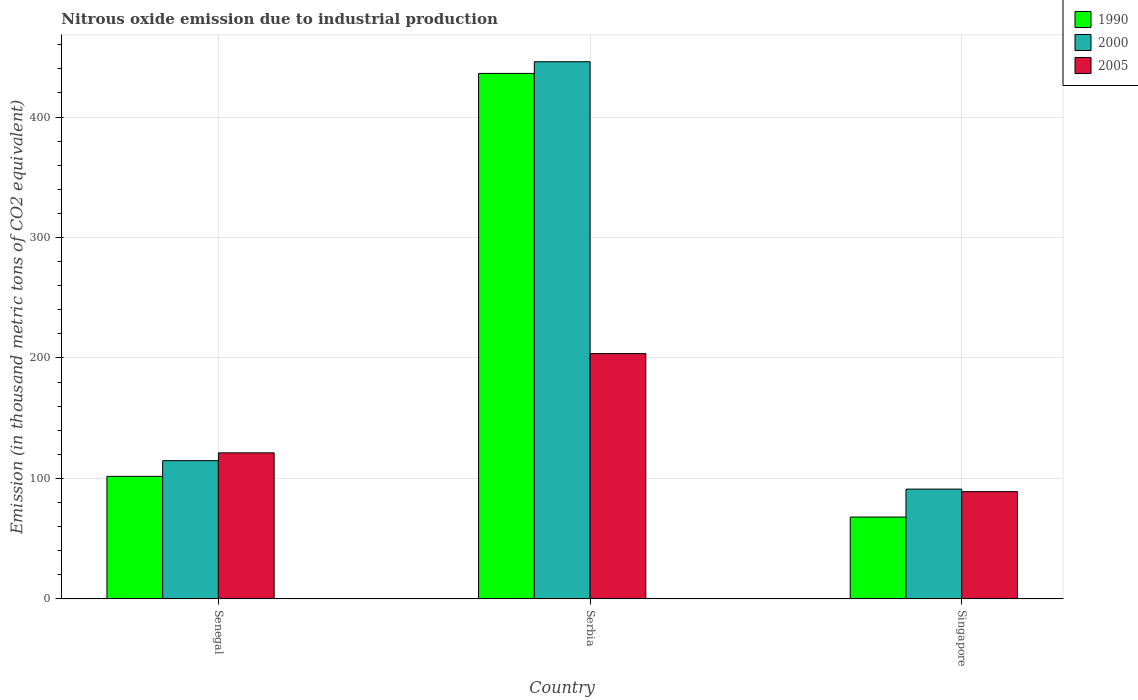How many different coloured bars are there?
Your answer should be compact. 3. Are the number of bars on each tick of the X-axis equal?
Provide a short and direct response. Yes. How many bars are there on the 2nd tick from the left?
Keep it short and to the point. 3. How many bars are there on the 3rd tick from the right?
Offer a very short reply. 3. What is the label of the 1st group of bars from the left?
Offer a terse response. Senegal. In how many cases, is the number of bars for a given country not equal to the number of legend labels?
Give a very brief answer. 0. What is the amount of nitrous oxide emitted in 2005 in Senegal?
Your answer should be very brief. 121.2. Across all countries, what is the maximum amount of nitrous oxide emitted in 2005?
Your answer should be very brief. 203.6. Across all countries, what is the minimum amount of nitrous oxide emitted in 2005?
Offer a very short reply. 89. In which country was the amount of nitrous oxide emitted in 2000 maximum?
Your response must be concise. Serbia. In which country was the amount of nitrous oxide emitted in 2005 minimum?
Provide a short and direct response. Singapore. What is the total amount of nitrous oxide emitted in 1990 in the graph?
Provide a short and direct response. 605.8. What is the difference between the amount of nitrous oxide emitted in 2005 in Serbia and that in Singapore?
Your answer should be very brief. 114.6. What is the difference between the amount of nitrous oxide emitted in 1990 in Singapore and the amount of nitrous oxide emitted in 2005 in Serbia?
Your response must be concise. -135.7. What is the average amount of nitrous oxide emitted in 2005 per country?
Your response must be concise. 137.93. What is the difference between the amount of nitrous oxide emitted of/in 2005 and amount of nitrous oxide emitted of/in 2000 in Singapore?
Your answer should be compact. -2.1. What is the ratio of the amount of nitrous oxide emitted in 2005 in Senegal to that in Serbia?
Offer a very short reply. 0.6. Is the difference between the amount of nitrous oxide emitted in 2005 in Serbia and Singapore greater than the difference between the amount of nitrous oxide emitted in 2000 in Serbia and Singapore?
Provide a short and direct response. No. What is the difference between the highest and the second highest amount of nitrous oxide emitted in 2000?
Your answer should be compact. 23.6. What is the difference between the highest and the lowest amount of nitrous oxide emitted in 2005?
Offer a terse response. 114.6. In how many countries, is the amount of nitrous oxide emitted in 1990 greater than the average amount of nitrous oxide emitted in 1990 taken over all countries?
Offer a terse response. 1. Is it the case that in every country, the sum of the amount of nitrous oxide emitted in 2000 and amount of nitrous oxide emitted in 1990 is greater than the amount of nitrous oxide emitted in 2005?
Your answer should be very brief. Yes. How many bars are there?
Make the answer very short. 9. Are all the bars in the graph horizontal?
Offer a very short reply. No. Does the graph contain any zero values?
Keep it short and to the point. No. Does the graph contain grids?
Make the answer very short. Yes. How many legend labels are there?
Give a very brief answer. 3. What is the title of the graph?
Give a very brief answer. Nitrous oxide emission due to industrial production. What is the label or title of the X-axis?
Ensure brevity in your answer.  Country. What is the label or title of the Y-axis?
Give a very brief answer. Emission (in thousand metric tons of CO2 equivalent). What is the Emission (in thousand metric tons of CO2 equivalent) of 1990 in Senegal?
Provide a succinct answer. 101.7. What is the Emission (in thousand metric tons of CO2 equivalent) of 2000 in Senegal?
Give a very brief answer. 114.7. What is the Emission (in thousand metric tons of CO2 equivalent) of 2005 in Senegal?
Your answer should be compact. 121.2. What is the Emission (in thousand metric tons of CO2 equivalent) of 1990 in Serbia?
Give a very brief answer. 436.2. What is the Emission (in thousand metric tons of CO2 equivalent) in 2000 in Serbia?
Give a very brief answer. 445.9. What is the Emission (in thousand metric tons of CO2 equivalent) in 2005 in Serbia?
Ensure brevity in your answer.  203.6. What is the Emission (in thousand metric tons of CO2 equivalent) of 1990 in Singapore?
Your response must be concise. 67.9. What is the Emission (in thousand metric tons of CO2 equivalent) in 2000 in Singapore?
Make the answer very short. 91.1. What is the Emission (in thousand metric tons of CO2 equivalent) in 2005 in Singapore?
Keep it short and to the point. 89. Across all countries, what is the maximum Emission (in thousand metric tons of CO2 equivalent) in 1990?
Your answer should be compact. 436.2. Across all countries, what is the maximum Emission (in thousand metric tons of CO2 equivalent) of 2000?
Keep it short and to the point. 445.9. Across all countries, what is the maximum Emission (in thousand metric tons of CO2 equivalent) in 2005?
Offer a terse response. 203.6. Across all countries, what is the minimum Emission (in thousand metric tons of CO2 equivalent) of 1990?
Make the answer very short. 67.9. Across all countries, what is the minimum Emission (in thousand metric tons of CO2 equivalent) of 2000?
Offer a terse response. 91.1. Across all countries, what is the minimum Emission (in thousand metric tons of CO2 equivalent) of 2005?
Your answer should be compact. 89. What is the total Emission (in thousand metric tons of CO2 equivalent) in 1990 in the graph?
Your response must be concise. 605.8. What is the total Emission (in thousand metric tons of CO2 equivalent) in 2000 in the graph?
Your response must be concise. 651.7. What is the total Emission (in thousand metric tons of CO2 equivalent) of 2005 in the graph?
Keep it short and to the point. 413.8. What is the difference between the Emission (in thousand metric tons of CO2 equivalent) in 1990 in Senegal and that in Serbia?
Your response must be concise. -334.5. What is the difference between the Emission (in thousand metric tons of CO2 equivalent) in 2000 in Senegal and that in Serbia?
Offer a very short reply. -331.2. What is the difference between the Emission (in thousand metric tons of CO2 equivalent) of 2005 in Senegal and that in Serbia?
Provide a succinct answer. -82.4. What is the difference between the Emission (in thousand metric tons of CO2 equivalent) in 1990 in Senegal and that in Singapore?
Ensure brevity in your answer.  33.8. What is the difference between the Emission (in thousand metric tons of CO2 equivalent) in 2000 in Senegal and that in Singapore?
Provide a short and direct response. 23.6. What is the difference between the Emission (in thousand metric tons of CO2 equivalent) in 2005 in Senegal and that in Singapore?
Your answer should be very brief. 32.2. What is the difference between the Emission (in thousand metric tons of CO2 equivalent) of 1990 in Serbia and that in Singapore?
Ensure brevity in your answer.  368.3. What is the difference between the Emission (in thousand metric tons of CO2 equivalent) of 2000 in Serbia and that in Singapore?
Your answer should be very brief. 354.8. What is the difference between the Emission (in thousand metric tons of CO2 equivalent) of 2005 in Serbia and that in Singapore?
Ensure brevity in your answer.  114.6. What is the difference between the Emission (in thousand metric tons of CO2 equivalent) of 1990 in Senegal and the Emission (in thousand metric tons of CO2 equivalent) of 2000 in Serbia?
Provide a succinct answer. -344.2. What is the difference between the Emission (in thousand metric tons of CO2 equivalent) in 1990 in Senegal and the Emission (in thousand metric tons of CO2 equivalent) in 2005 in Serbia?
Your answer should be very brief. -101.9. What is the difference between the Emission (in thousand metric tons of CO2 equivalent) of 2000 in Senegal and the Emission (in thousand metric tons of CO2 equivalent) of 2005 in Serbia?
Your response must be concise. -88.9. What is the difference between the Emission (in thousand metric tons of CO2 equivalent) in 1990 in Senegal and the Emission (in thousand metric tons of CO2 equivalent) in 2000 in Singapore?
Give a very brief answer. 10.6. What is the difference between the Emission (in thousand metric tons of CO2 equivalent) of 1990 in Senegal and the Emission (in thousand metric tons of CO2 equivalent) of 2005 in Singapore?
Provide a succinct answer. 12.7. What is the difference between the Emission (in thousand metric tons of CO2 equivalent) of 2000 in Senegal and the Emission (in thousand metric tons of CO2 equivalent) of 2005 in Singapore?
Keep it short and to the point. 25.7. What is the difference between the Emission (in thousand metric tons of CO2 equivalent) of 1990 in Serbia and the Emission (in thousand metric tons of CO2 equivalent) of 2000 in Singapore?
Provide a succinct answer. 345.1. What is the difference between the Emission (in thousand metric tons of CO2 equivalent) in 1990 in Serbia and the Emission (in thousand metric tons of CO2 equivalent) in 2005 in Singapore?
Ensure brevity in your answer.  347.2. What is the difference between the Emission (in thousand metric tons of CO2 equivalent) in 2000 in Serbia and the Emission (in thousand metric tons of CO2 equivalent) in 2005 in Singapore?
Your answer should be compact. 356.9. What is the average Emission (in thousand metric tons of CO2 equivalent) of 1990 per country?
Provide a succinct answer. 201.93. What is the average Emission (in thousand metric tons of CO2 equivalent) of 2000 per country?
Offer a very short reply. 217.23. What is the average Emission (in thousand metric tons of CO2 equivalent) of 2005 per country?
Make the answer very short. 137.93. What is the difference between the Emission (in thousand metric tons of CO2 equivalent) of 1990 and Emission (in thousand metric tons of CO2 equivalent) of 2005 in Senegal?
Provide a short and direct response. -19.5. What is the difference between the Emission (in thousand metric tons of CO2 equivalent) in 1990 and Emission (in thousand metric tons of CO2 equivalent) in 2005 in Serbia?
Offer a very short reply. 232.6. What is the difference between the Emission (in thousand metric tons of CO2 equivalent) in 2000 and Emission (in thousand metric tons of CO2 equivalent) in 2005 in Serbia?
Your response must be concise. 242.3. What is the difference between the Emission (in thousand metric tons of CO2 equivalent) in 1990 and Emission (in thousand metric tons of CO2 equivalent) in 2000 in Singapore?
Keep it short and to the point. -23.2. What is the difference between the Emission (in thousand metric tons of CO2 equivalent) in 1990 and Emission (in thousand metric tons of CO2 equivalent) in 2005 in Singapore?
Provide a succinct answer. -21.1. What is the ratio of the Emission (in thousand metric tons of CO2 equivalent) of 1990 in Senegal to that in Serbia?
Offer a very short reply. 0.23. What is the ratio of the Emission (in thousand metric tons of CO2 equivalent) of 2000 in Senegal to that in Serbia?
Your response must be concise. 0.26. What is the ratio of the Emission (in thousand metric tons of CO2 equivalent) of 2005 in Senegal to that in Serbia?
Your answer should be very brief. 0.6. What is the ratio of the Emission (in thousand metric tons of CO2 equivalent) of 1990 in Senegal to that in Singapore?
Keep it short and to the point. 1.5. What is the ratio of the Emission (in thousand metric tons of CO2 equivalent) in 2000 in Senegal to that in Singapore?
Offer a terse response. 1.26. What is the ratio of the Emission (in thousand metric tons of CO2 equivalent) in 2005 in Senegal to that in Singapore?
Give a very brief answer. 1.36. What is the ratio of the Emission (in thousand metric tons of CO2 equivalent) in 1990 in Serbia to that in Singapore?
Your response must be concise. 6.42. What is the ratio of the Emission (in thousand metric tons of CO2 equivalent) of 2000 in Serbia to that in Singapore?
Offer a terse response. 4.89. What is the ratio of the Emission (in thousand metric tons of CO2 equivalent) of 2005 in Serbia to that in Singapore?
Your answer should be compact. 2.29. What is the difference between the highest and the second highest Emission (in thousand metric tons of CO2 equivalent) in 1990?
Offer a terse response. 334.5. What is the difference between the highest and the second highest Emission (in thousand metric tons of CO2 equivalent) in 2000?
Make the answer very short. 331.2. What is the difference between the highest and the second highest Emission (in thousand metric tons of CO2 equivalent) of 2005?
Your response must be concise. 82.4. What is the difference between the highest and the lowest Emission (in thousand metric tons of CO2 equivalent) of 1990?
Your answer should be compact. 368.3. What is the difference between the highest and the lowest Emission (in thousand metric tons of CO2 equivalent) in 2000?
Your answer should be very brief. 354.8. What is the difference between the highest and the lowest Emission (in thousand metric tons of CO2 equivalent) in 2005?
Make the answer very short. 114.6. 